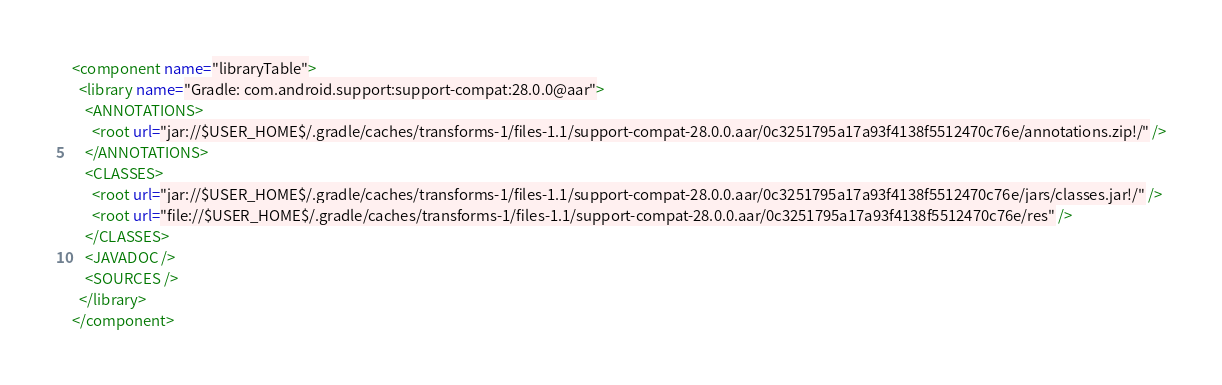Convert code to text. <code><loc_0><loc_0><loc_500><loc_500><_XML_><component name="libraryTable">
  <library name="Gradle: com.android.support:support-compat:28.0.0@aar">
    <ANNOTATIONS>
      <root url="jar://$USER_HOME$/.gradle/caches/transforms-1/files-1.1/support-compat-28.0.0.aar/0c3251795a17a93f4138f5512470c76e/annotations.zip!/" />
    </ANNOTATIONS>
    <CLASSES>
      <root url="jar://$USER_HOME$/.gradle/caches/transforms-1/files-1.1/support-compat-28.0.0.aar/0c3251795a17a93f4138f5512470c76e/jars/classes.jar!/" />
      <root url="file://$USER_HOME$/.gradle/caches/transforms-1/files-1.1/support-compat-28.0.0.aar/0c3251795a17a93f4138f5512470c76e/res" />
    </CLASSES>
    <JAVADOC />
    <SOURCES />
  </library>
</component></code> 